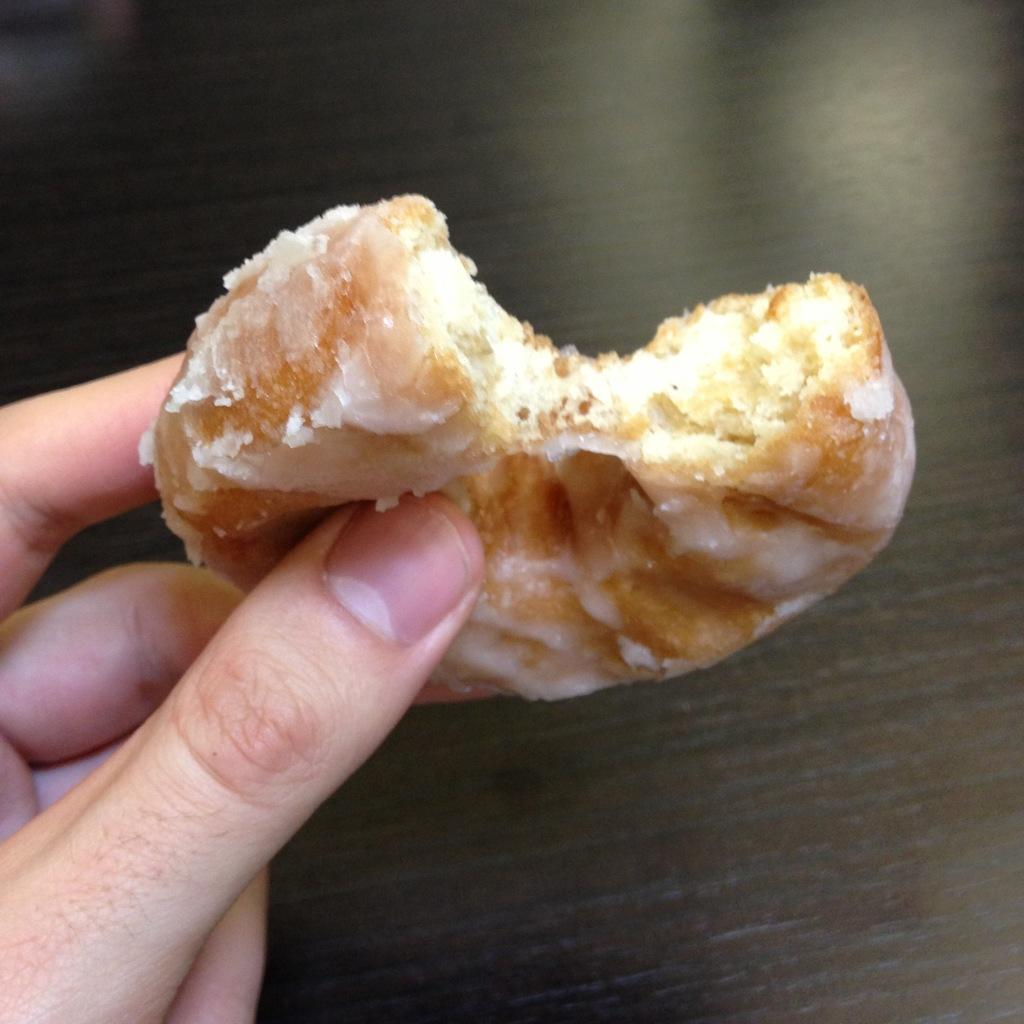What is present in the image? There is a person in the image. What is the person holding? The person is holding a food item. Can you describe the appearance of the food item? The food has brown and white colors. What is the color of the background in the image? The background in the image is black. What type of yam is being used as a frame for the person in the image? There is no yam or frame present in the image; it features a person holding a food item against a black background. 